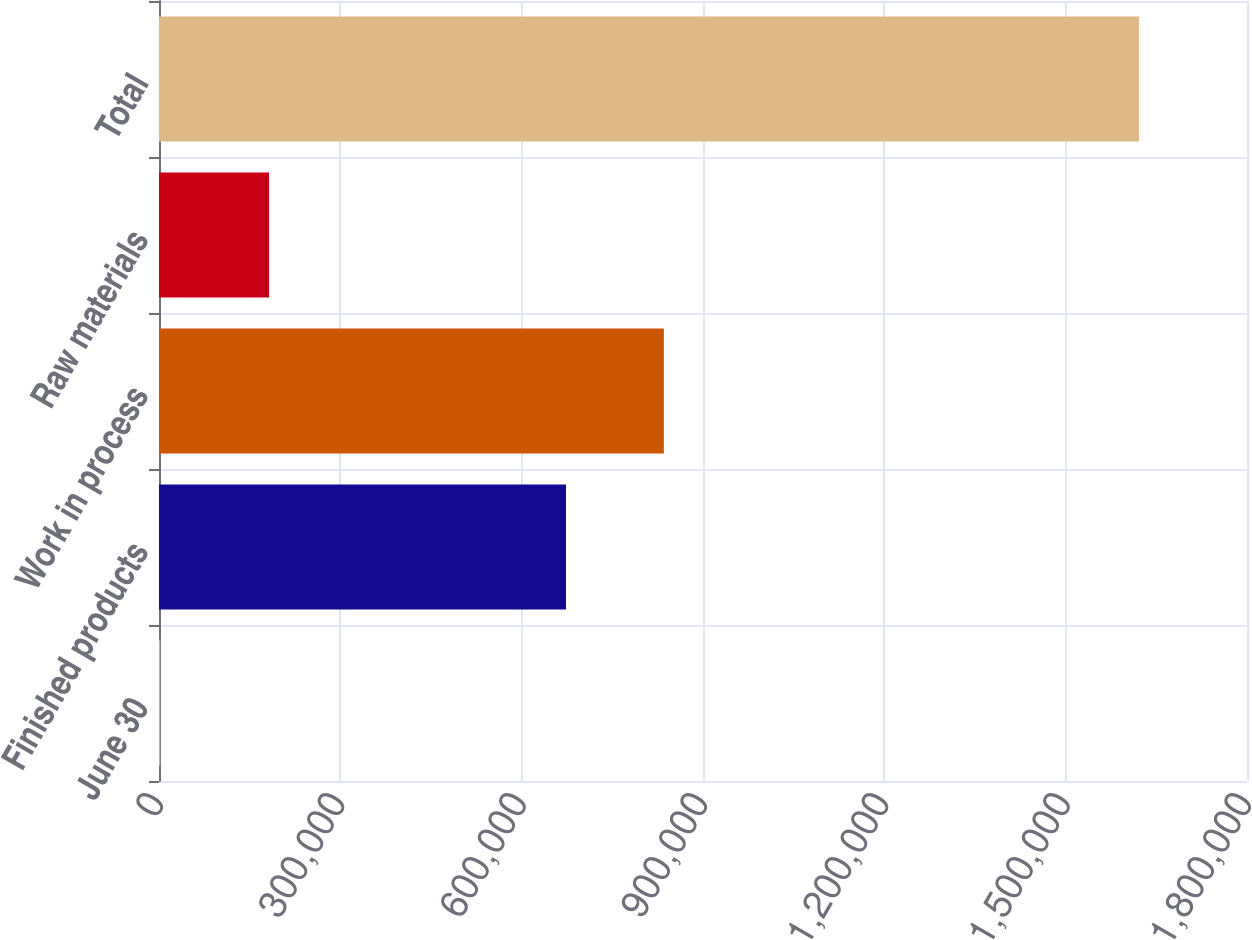Convert chart to OTSL. <chart><loc_0><loc_0><loc_500><loc_500><bar_chart><fcel>June 30<fcel>Finished products<fcel>Work in process<fcel>Raw materials<fcel>Total<nl><fcel>2018<fcel>673323<fcel>835252<fcel>182146<fcel>1.6213e+06<nl></chart> 